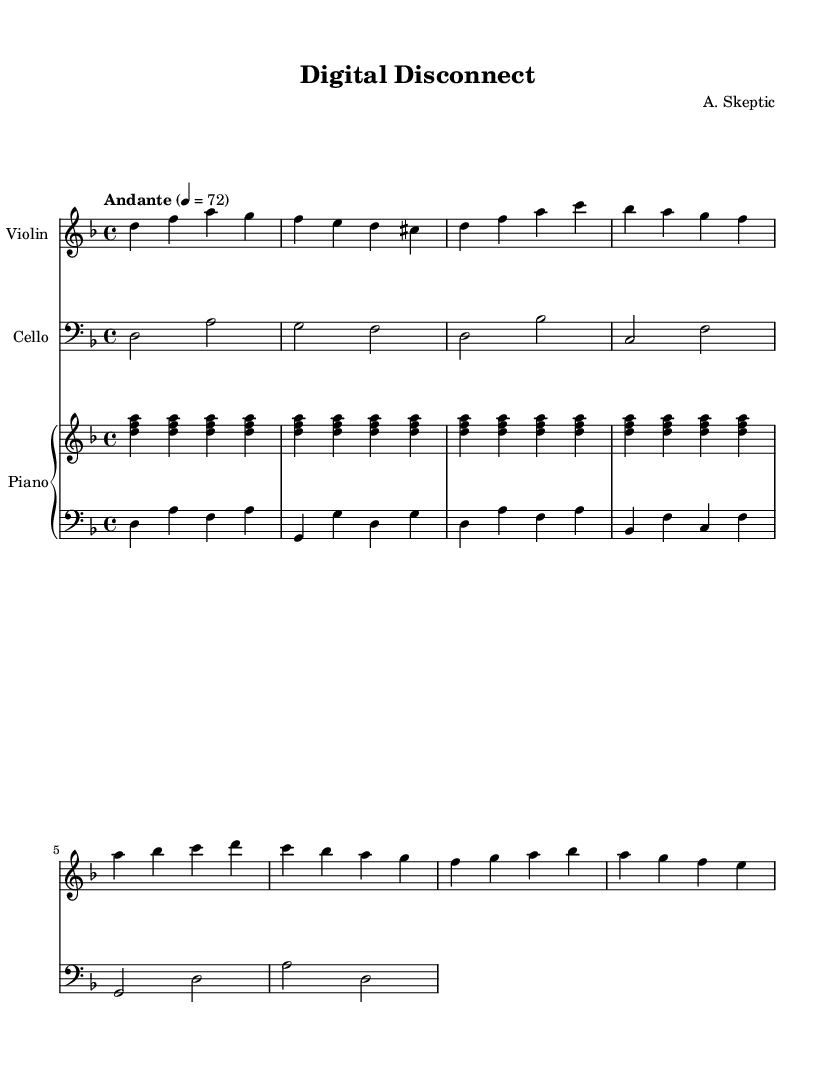What is the key signature of this piece? The key signature shows two flats (B♭ and E♭) indicating D minor.
Answer: D minor What is the time signature of this composition? The time signature is indicated at the beginning of the staff and shows a 4 over 4 position, meaning there are four beats per measure and a quarter note gets one beat.
Answer: 4/4 What is the tempo marking for this piece? The tempo marking is found above the staff, which specifies a moderate tempo of "Andante" at quarter note equals 72 beats per minute.
Answer: Andante How many measures are in the violin part? The violin part consists of two sections, and upon counting the measures displayed, there are eight measures in total.
Answer: 8 What instruments are featured in this piece? The score provides three distinct staves that represent three instruments: the violin, cello, and piano, specifically dividing the piano into right and left hands.
Answer: Violin, Cello, Piano In which clef is the cello part written? The cello part is written in the bass clef, which is identified by the clef symbol placed at the beginning of the cello staff.
Answer: Bass clef What is the first note of the cello section? The first note in the cello section is indicated by the position on the staff and the note head, which is D, presented as a whole note.
Answer: D 